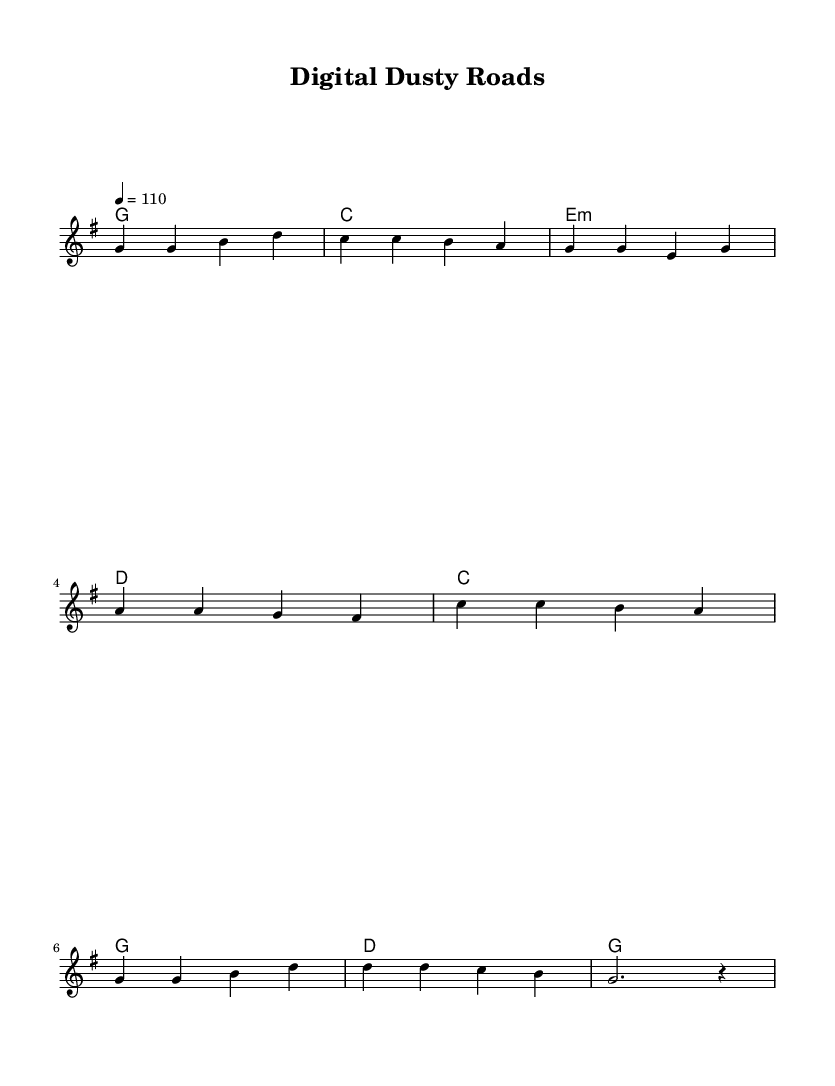What is the key signature of this music? The key signature is G major, which has one sharp, F#.
Answer: G major What is the time signature of this music? The time signature is 4/4, which means there are four beats per measure.
Answer: 4/4 What is the tempo marking indicated in the music? The tempo marking is a quarter note equals 110 beats per minute.
Answer: 110 How many verses are there in this song? There is one verse indicated in the lyrics section, which is followed by a chorus.
Answer: One What chords are used in the chorus? The chords used in the chorus are C, G, D, and G again on the last measure.
Answer: C, G, D, G What is the thematic focus of the lyrics in this piece? The thematic focus is on the evolution of information storage, referencing various technologies over time.
Answer: Evolution of information storage How does the melody of the verse compare to the chorus in terms of pitch range? The verse generally stays within a lower pitch range, while the chorus includes a higher starting note of C.
Answer: Higher pitch in chorus 